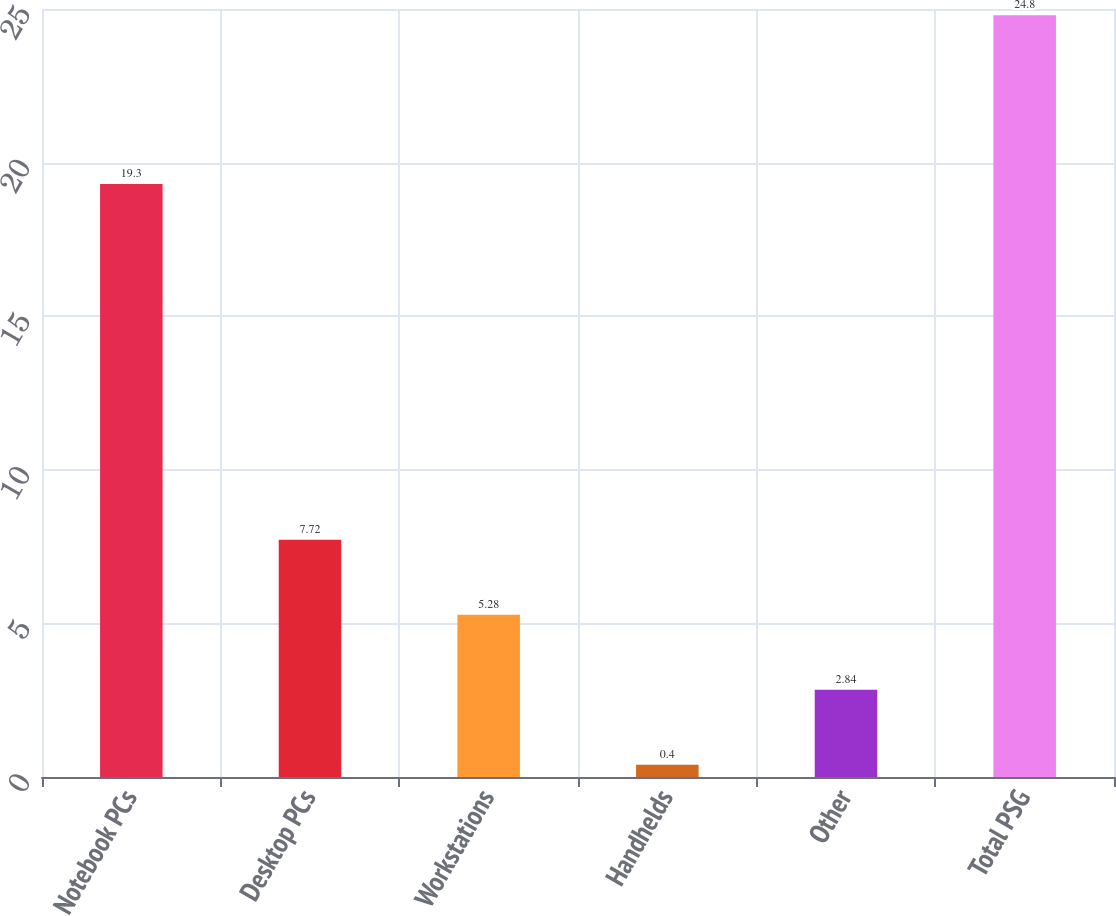Convert chart to OTSL. <chart><loc_0><loc_0><loc_500><loc_500><bar_chart><fcel>Notebook PCs<fcel>Desktop PCs<fcel>Workstations<fcel>Handhelds<fcel>Other<fcel>Total PSG<nl><fcel>19.3<fcel>7.72<fcel>5.28<fcel>0.4<fcel>2.84<fcel>24.8<nl></chart> 